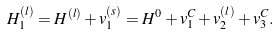Convert formula to latex. <formula><loc_0><loc_0><loc_500><loc_500>H _ { 1 } ^ { ( l ) } = H ^ { ( l ) } + v _ { 1 } ^ { ( s ) } = H ^ { 0 } + v _ { 1 } ^ { C } + v _ { 2 } ^ { ( l ) } + v _ { 3 } ^ { C } .</formula> 